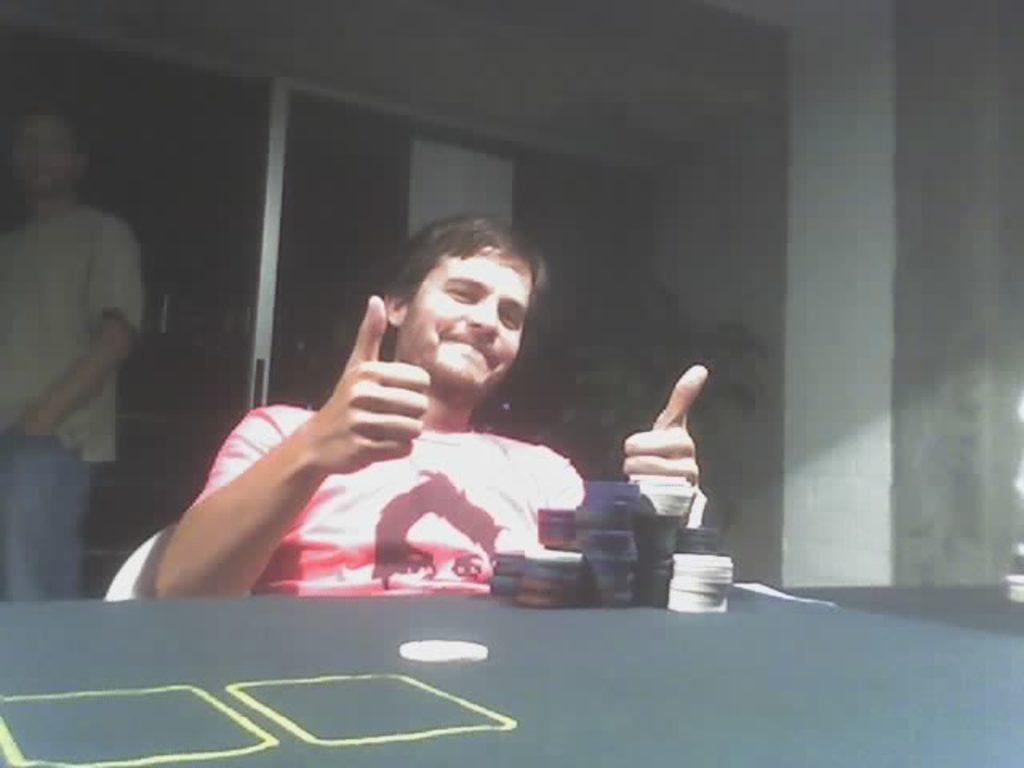What is the person in the image doing? There is a person sitting on a chair in the image. What objects can be seen on the table in the image? There are coins on a table in the image. What is visible in the background of the image? There is a wall visible in the image. Can you describe the other person in the image? There is a person standing near the wall in the image. What type of government is depicted in the image? There is no depiction of a government in the image; it features a person sitting on a chair, coins on a table, a wall, and another person standing near the wall. Can you tell me how many kittens are present in the image? There are no kittens present in the image. 